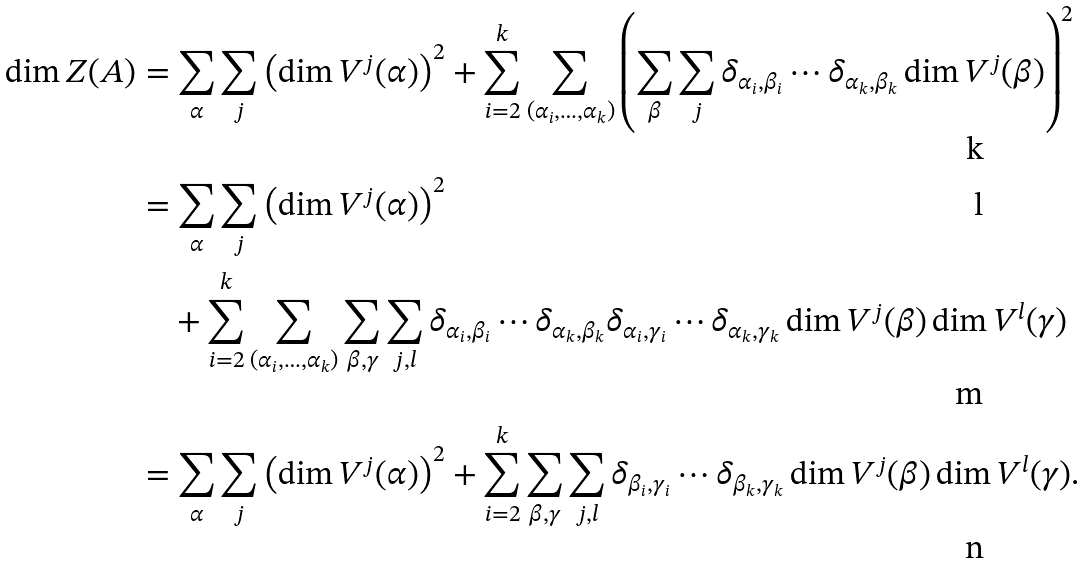<formula> <loc_0><loc_0><loc_500><loc_500>\dim Z ( A ) & = \sum _ { \alpha } \sum _ { j } \left ( \dim V ^ { j } ( \alpha ) \right ) ^ { 2 } + \sum _ { i = 2 } ^ { k } \sum _ { ( \alpha _ { i } , \dots , \alpha _ { k } ) } \left ( \sum _ { \beta } \sum _ { j } \delta _ { \alpha _ { i } , \beta _ { i } } \cdots \delta _ { \alpha _ { k } , \beta _ { k } } \dim V ^ { j } ( \beta ) \right ) ^ { 2 } \\ & = \sum _ { \alpha } \sum _ { j } \left ( \dim V ^ { j } ( \alpha ) \right ) ^ { 2 } \\ & \quad + \sum _ { i = 2 } ^ { k } \sum _ { ( \alpha _ { i } , \dots , \alpha _ { k } ) } \sum _ { \beta , \gamma } \sum _ { j , l } \delta _ { \alpha _ { i } , \beta _ { i } } \cdots \delta _ { \alpha _ { k } , \beta _ { k } } \delta _ { \alpha _ { i } , \gamma _ { i } } \cdots \delta _ { \alpha _ { k } , \gamma _ { k } } \dim V ^ { j } ( \beta ) \dim V ^ { l } ( \gamma ) \\ & = \sum _ { \alpha } \sum _ { j } \left ( \dim V ^ { j } ( \alpha ) \right ) ^ { 2 } + \sum _ { i = 2 } ^ { k } \sum _ { \beta , \gamma } \sum _ { j , l } \delta _ { \beta _ { i } , \gamma _ { i } } \cdots \delta _ { \beta _ { k } , \gamma _ { k } } \dim V ^ { j } ( \beta ) \dim V ^ { l } ( \gamma ) .</formula> 